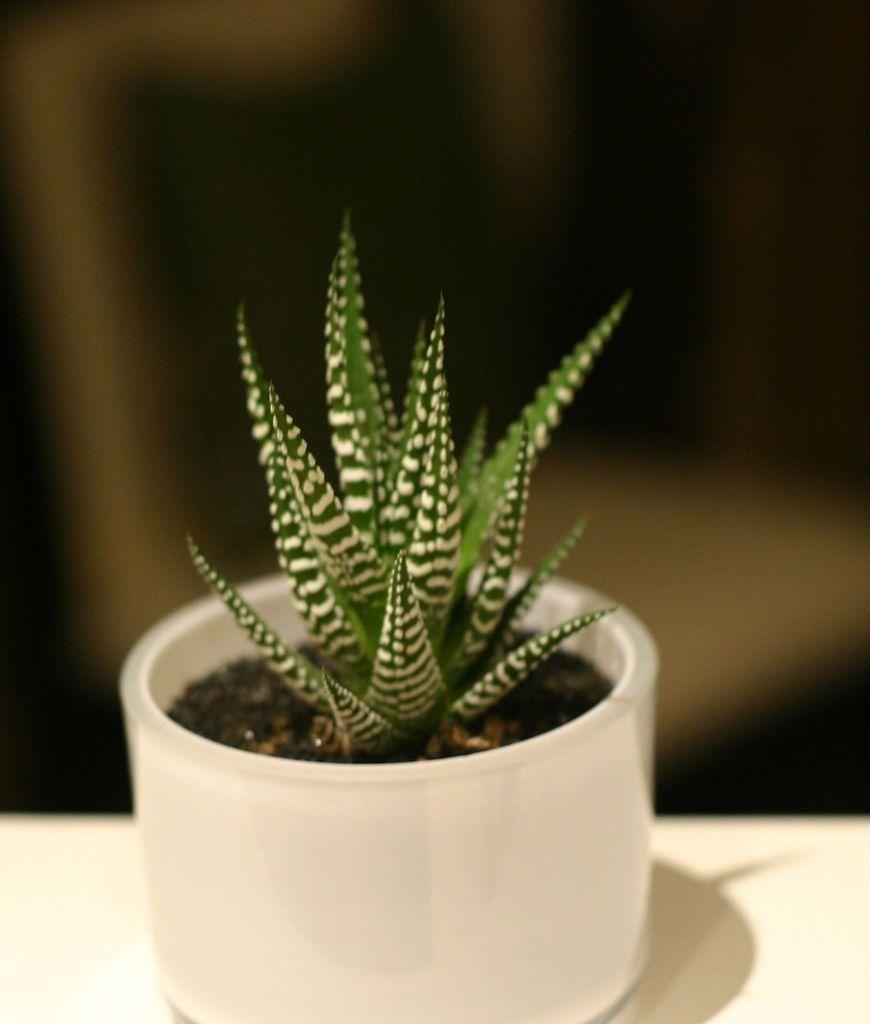Describe this image in one or two sentences. In this picture we can see a plant on this white pot. This pot is kept on the wall. 